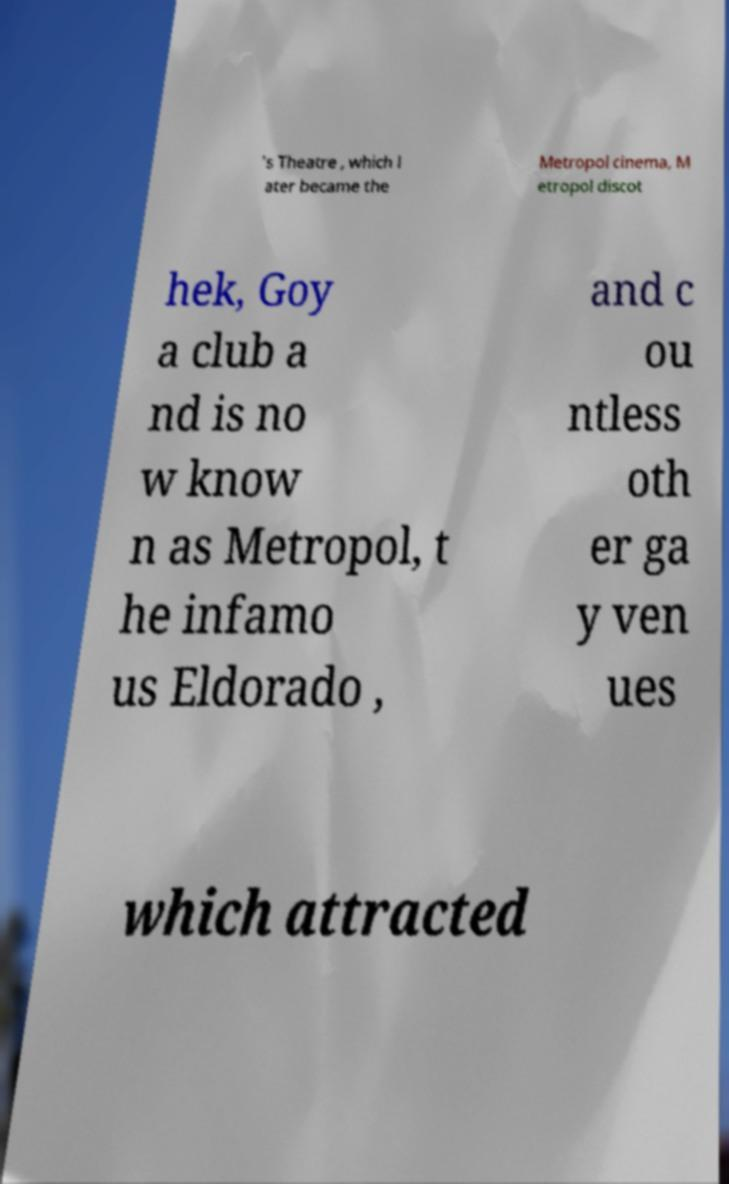Can you accurately transcribe the text from the provided image for me? 's Theatre , which l ater became the Metropol cinema, M etropol discot hek, Goy a club a nd is no w know n as Metropol, t he infamo us Eldorado , and c ou ntless oth er ga y ven ues which attracted 